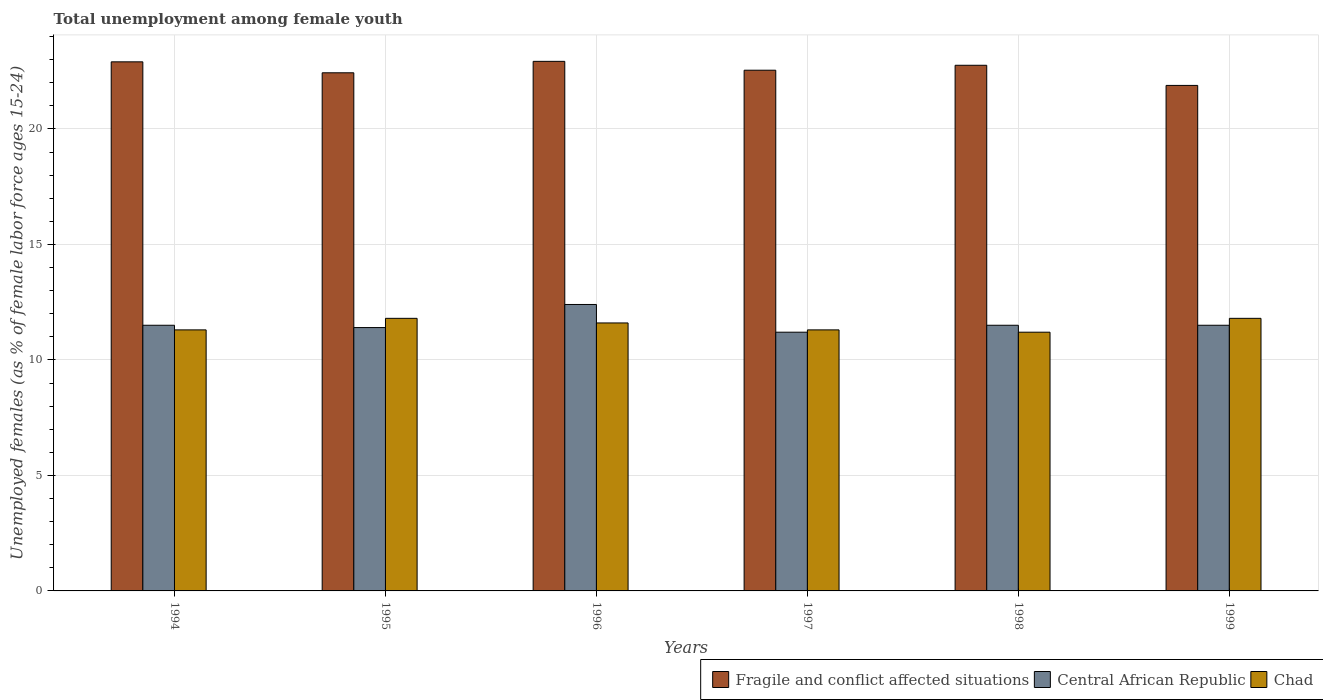How many different coloured bars are there?
Offer a very short reply. 3. How many groups of bars are there?
Your answer should be compact. 6. Are the number of bars per tick equal to the number of legend labels?
Offer a very short reply. Yes. Are the number of bars on each tick of the X-axis equal?
Your answer should be compact. Yes. How many bars are there on the 4th tick from the left?
Ensure brevity in your answer.  3. How many bars are there on the 1st tick from the right?
Make the answer very short. 3. What is the percentage of unemployed females in in Central African Republic in 1996?
Offer a very short reply. 12.4. Across all years, what is the maximum percentage of unemployed females in in Central African Republic?
Provide a short and direct response. 12.4. Across all years, what is the minimum percentage of unemployed females in in Fragile and conflict affected situations?
Your answer should be very brief. 21.88. What is the total percentage of unemployed females in in Central African Republic in the graph?
Your response must be concise. 69.5. What is the difference between the percentage of unemployed females in in Central African Republic in 1994 and that in 1995?
Give a very brief answer. 0.1. What is the difference between the percentage of unemployed females in in Fragile and conflict affected situations in 1998 and the percentage of unemployed females in in Central African Republic in 1995?
Provide a short and direct response. 11.35. What is the average percentage of unemployed females in in Fragile and conflict affected situations per year?
Ensure brevity in your answer.  22.57. In the year 1996, what is the difference between the percentage of unemployed females in in Central African Republic and percentage of unemployed females in in Fragile and conflict affected situations?
Provide a succinct answer. -10.52. What is the ratio of the percentage of unemployed females in in Chad in 1994 to that in 1996?
Provide a succinct answer. 0.97. Is the percentage of unemployed females in in Chad in 1995 less than that in 1996?
Offer a very short reply. No. What is the difference between the highest and the second highest percentage of unemployed females in in Chad?
Your answer should be compact. 0. What is the difference between the highest and the lowest percentage of unemployed females in in Fragile and conflict affected situations?
Your answer should be very brief. 1.04. What does the 2nd bar from the left in 1997 represents?
Ensure brevity in your answer.  Central African Republic. What does the 1st bar from the right in 1997 represents?
Your response must be concise. Chad. Is it the case that in every year, the sum of the percentage of unemployed females in in Chad and percentage of unemployed females in in Central African Republic is greater than the percentage of unemployed females in in Fragile and conflict affected situations?
Provide a short and direct response. No. How many years are there in the graph?
Provide a short and direct response. 6. Are the values on the major ticks of Y-axis written in scientific E-notation?
Ensure brevity in your answer.  No. What is the title of the graph?
Keep it short and to the point. Total unemployment among female youth. What is the label or title of the X-axis?
Your answer should be very brief. Years. What is the label or title of the Y-axis?
Your answer should be very brief. Unemployed females (as % of female labor force ages 15-24). What is the Unemployed females (as % of female labor force ages 15-24) of Fragile and conflict affected situations in 1994?
Provide a succinct answer. 22.9. What is the Unemployed females (as % of female labor force ages 15-24) of Central African Republic in 1994?
Keep it short and to the point. 11.5. What is the Unemployed females (as % of female labor force ages 15-24) of Chad in 1994?
Give a very brief answer. 11.3. What is the Unemployed females (as % of female labor force ages 15-24) of Fragile and conflict affected situations in 1995?
Ensure brevity in your answer.  22.43. What is the Unemployed females (as % of female labor force ages 15-24) of Central African Republic in 1995?
Offer a very short reply. 11.4. What is the Unemployed females (as % of female labor force ages 15-24) in Chad in 1995?
Provide a succinct answer. 11.8. What is the Unemployed females (as % of female labor force ages 15-24) in Fragile and conflict affected situations in 1996?
Keep it short and to the point. 22.92. What is the Unemployed females (as % of female labor force ages 15-24) in Central African Republic in 1996?
Ensure brevity in your answer.  12.4. What is the Unemployed females (as % of female labor force ages 15-24) in Chad in 1996?
Offer a terse response. 11.6. What is the Unemployed females (as % of female labor force ages 15-24) in Fragile and conflict affected situations in 1997?
Your response must be concise. 22.54. What is the Unemployed females (as % of female labor force ages 15-24) in Central African Republic in 1997?
Your answer should be compact. 11.2. What is the Unemployed females (as % of female labor force ages 15-24) of Chad in 1997?
Make the answer very short. 11.3. What is the Unemployed females (as % of female labor force ages 15-24) of Fragile and conflict affected situations in 1998?
Your answer should be very brief. 22.75. What is the Unemployed females (as % of female labor force ages 15-24) in Chad in 1998?
Provide a succinct answer. 11.2. What is the Unemployed females (as % of female labor force ages 15-24) of Fragile and conflict affected situations in 1999?
Give a very brief answer. 21.88. What is the Unemployed females (as % of female labor force ages 15-24) in Central African Republic in 1999?
Keep it short and to the point. 11.5. What is the Unemployed females (as % of female labor force ages 15-24) of Chad in 1999?
Keep it short and to the point. 11.8. Across all years, what is the maximum Unemployed females (as % of female labor force ages 15-24) of Fragile and conflict affected situations?
Offer a very short reply. 22.92. Across all years, what is the maximum Unemployed females (as % of female labor force ages 15-24) of Central African Republic?
Give a very brief answer. 12.4. Across all years, what is the maximum Unemployed females (as % of female labor force ages 15-24) of Chad?
Keep it short and to the point. 11.8. Across all years, what is the minimum Unemployed females (as % of female labor force ages 15-24) of Fragile and conflict affected situations?
Offer a terse response. 21.88. Across all years, what is the minimum Unemployed females (as % of female labor force ages 15-24) of Central African Republic?
Provide a succinct answer. 11.2. Across all years, what is the minimum Unemployed females (as % of female labor force ages 15-24) of Chad?
Give a very brief answer. 11.2. What is the total Unemployed females (as % of female labor force ages 15-24) in Fragile and conflict affected situations in the graph?
Your answer should be compact. 135.43. What is the total Unemployed females (as % of female labor force ages 15-24) of Central African Republic in the graph?
Your answer should be compact. 69.5. What is the difference between the Unemployed females (as % of female labor force ages 15-24) in Fragile and conflict affected situations in 1994 and that in 1995?
Ensure brevity in your answer.  0.47. What is the difference between the Unemployed females (as % of female labor force ages 15-24) in Fragile and conflict affected situations in 1994 and that in 1996?
Your response must be concise. -0.02. What is the difference between the Unemployed females (as % of female labor force ages 15-24) in Fragile and conflict affected situations in 1994 and that in 1997?
Provide a succinct answer. 0.36. What is the difference between the Unemployed females (as % of female labor force ages 15-24) in Fragile and conflict affected situations in 1994 and that in 1998?
Provide a short and direct response. 0.15. What is the difference between the Unemployed females (as % of female labor force ages 15-24) of Chad in 1994 and that in 1998?
Offer a very short reply. 0.1. What is the difference between the Unemployed females (as % of female labor force ages 15-24) of Fragile and conflict affected situations in 1994 and that in 1999?
Provide a succinct answer. 1.02. What is the difference between the Unemployed females (as % of female labor force ages 15-24) in Central African Republic in 1994 and that in 1999?
Keep it short and to the point. 0. What is the difference between the Unemployed females (as % of female labor force ages 15-24) in Chad in 1994 and that in 1999?
Your answer should be compact. -0.5. What is the difference between the Unemployed females (as % of female labor force ages 15-24) of Fragile and conflict affected situations in 1995 and that in 1996?
Offer a very short reply. -0.5. What is the difference between the Unemployed females (as % of female labor force ages 15-24) in Central African Republic in 1995 and that in 1996?
Give a very brief answer. -1. What is the difference between the Unemployed females (as % of female labor force ages 15-24) in Chad in 1995 and that in 1996?
Provide a short and direct response. 0.2. What is the difference between the Unemployed females (as % of female labor force ages 15-24) in Fragile and conflict affected situations in 1995 and that in 1997?
Your response must be concise. -0.11. What is the difference between the Unemployed females (as % of female labor force ages 15-24) in Fragile and conflict affected situations in 1995 and that in 1998?
Your answer should be very brief. -0.33. What is the difference between the Unemployed females (as % of female labor force ages 15-24) of Central African Republic in 1995 and that in 1998?
Offer a very short reply. -0.1. What is the difference between the Unemployed females (as % of female labor force ages 15-24) of Chad in 1995 and that in 1998?
Your response must be concise. 0.6. What is the difference between the Unemployed females (as % of female labor force ages 15-24) of Fragile and conflict affected situations in 1995 and that in 1999?
Ensure brevity in your answer.  0.55. What is the difference between the Unemployed females (as % of female labor force ages 15-24) of Central African Republic in 1995 and that in 1999?
Your response must be concise. -0.1. What is the difference between the Unemployed females (as % of female labor force ages 15-24) in Chad in 1995 and that in 1999?
Give a very brief answer. 0. What is the difference between the Unemployed females (as % of female labor force ages 15-24) of Fragile and conflict affected situations in 1996 and that in 1997?
Offer a terse response. 0.38. What is the difference between the Unemployed females (as % of female labor force ages 15-24) of Chad in 1996 and that in 1997?
Provide a short and direct response. 0.3. What is the difference between the Unemployed females (as % of female labor force ages 15-24) of Fragile and conflict affected situations in 1996 and that in 1998?
Provide a short and direct response. 0.17. What is the difference between the Unemployed females (as % of female labor force ages 15-24) in Central African Republic in 1996 and that in 1998?
Ensure brevity in your answer.  0.9. What is the difference between the Unemployed females (as % of female labor force ages 15-24) of Fragile and conflict affected situations in 1996 and that in 1999?
Offer a terse response. 1.04. What is the difference between the Unemployed females (as % of female labor force ages 15-24) of Central African Republic in 1996 and that in 1999?
Ensure brevity in your answer.  0.9. What is the difference between the Unemployed females (as % of female labor force ages 15-24) in Chad in 1996 and that in 1999?
Keep it short and to the point. -0.2. What is the difference between the Unemployed females (as % of female labor force ages 15-24) of Fragile and conflict affected situations in 1997 and that in 1998?
Offer a very short reply. -0.21. What is the difference between the Unemployed females (as % of female labor force ages 15-24) in Fragile and conflict affected situations in 1997 and that in 1999?
Ensure brevity in your answer.  0.66. What is the difference between the Unemployed females (as % of female labor force ages 15-24) in Chad in 1997 and that in 1999?
Give a very brief answer. -0.5. What is the difference between the Unemployed females (as % of female labor force ages 15-24) in Fragile and conflict affected situations in 1998 and that in 1999?
Make the answer very short. 0.87. What is the difference between the Unemployed females (as % of female labor force ages 15-24) of Central African Republic in 1998 and that in 1999?
Provide a short and direct response. 0. What is the difference between the Unemployed females (as % of female labor force ages 15-24) of Fragile and conflict affected situations in 1994 and the Unemployed females (as % of female labor force ages 15-24) of Central African Republic in 1995?
Your response must be concise. 11.5. What is the difference between the Unemployed females (as % of female labor force ages 15-24) in Fragile and conflict affected situations in 1994 and the Unemployed females (as % of female labor force ages 15-24) in Chad in 1995?
Provide a short and direct response. 11.1. What is the difference between the Unemployed females (as % of female labor force ages 15-24) of Central African Republic in 1994 and the Unemployed females (as % of female labor force ages 15-24) of Chad in 1995?
Provide a succinct answer. -0.3. What is the difference between the Unemployed females (as % of female labor force ages 15-24) in Fragile and conflict affected situations in 1994 and the Unemployed females (as % of female labor force ages 15-24) in Central African Republic in 1996?
Keep it short and to the point. 10.5. What is the difference between the Unemployed females (as % of female labor force ages 15-24) of Fragile and conflict affected situations in 1994 and the Unemployed females (as % of female labor force ages 15-24) of Chad in 1996?
Keep it short and to the point. 11.3. What is the difference between the Unemployed females (as % of female labor force ages 15-24) of Fragile and conflict affected situations in 1994 and the Unemployed females (as % of female labor force ages 15-24) of Central African Republic in 1997?
Ensure brevity in your answer.  11.7. What is the difference between the Unemployed females (as % of female labor force ages 15-24) of Fragile and conflict affected situations in 1994 and the Unemployed females (as % of female labor force ages 15-24) of Chad in 1997?
Give a very brief answer. 11.6. What is the difference between the Unemployed females (as % of female labor force ages 15-24) in Central African Republic in 1994 and the Unemployed females (as % of female labor force ages 15-24) in Chad in 1997?
Keep it short and to the point. 0.2. What is the difference between the Unemployed females (as % of female labor force ages 15-24) of Fragile and conflict affected situations in 1994 and the Unemployed females (as % of female labor force ages 15-24) of Central African Republic in 1998?
Give a very brief answer. 11.4. What is the difference between the Unemployed females (as % of female labor force ages 15-24) in Fragile and conflict affected situations in 1994 and the Unemployed females (as % of female labor force ages 15-24) in Chad in 1998?
Ensure brevity in your answer.  11.7. What is the difference between the Unemployed females (as % of female labor force ages 15-24) of Central African Republic in 1994 and the Unemployed females (as % of female labor force ages 15-24) of Chad in 1998?
Offer a very short reply. 0.3. What is the difference between the Unemployed females (as % of female labor force ages 15-24) of Fragile and conflict affected situations in 1994 and the Unemployed females (as % of female labor force ages 15-24) of Central African Republic in 1999?
Ensure brevity in your answer.  11.4. What is the difference between the Unemployed females (as % of female labor force ages 15-24) in Fragile and conflict affected situations in 1994 and the Unemployed females (as % of female labor force ages 15-24) in Chad in 1999?
Offer a terse response. 11.1. What is the difference between the Unemployed females (as % of female labor force ages 15-24) of Central African Republic in 1994 and the Unemployed females (as % of female labor force ages 15-24) of Chad in 1999?
Offer a terse response. -0.3. What is the difference between the Unemployed females (as % of female labor force ages 15-24) of Fragile and conflict affected situations in 1995 and the Unemployed females (as % of female labor force ages 15-24) of Central African Republic in 1996?
Offer a terse response. 10.03. What is the difference between the Unemployed females (as % of female labor force ages 15-24) in Fragile and conflict affected situations in 1995 and the Unemployed females (as % of female labor force ages 15-24) in Chad in 1996?
Keep it short and to the point. 10.83. What is the difference between the Unemployed females (as % of female labor force ages 15-24) of Fragile and conflict affected situations in 1995 and the Unemployed females (as % of female labor force ages 15-24) of Central African Republic in 1997?
Give a very brief answer. 11.23. What is the difference between the Unemployed females (as % of female labor force ages 15-24) of Fragile and conflict affected situations in 1995 and the Unemployed females (as % of female labor force ages 15-24) of Chad in 1997?
Keep it short and to the point. 11.13. What is the difference between the Unemployed females (as % of female labor force ages 15-24) of Fragile and conflict affected situations in 1995 and the Unemployed females (as % of female labor force ages 15-24) of Central African Republic in 1998?
Your answer should be very brief. 10.93. What is the difference between the Unemployed females (as % of female labor force ages 15-24) of Fragile and conflict affected situations in 1995 and the Unemployed females (as % of female labor force ages 15-24) of Chad in 1998?
Offer a terse response. 11.23. What is the difference between the Unemployed females (as % of female labor force ages 15-24) in Fragile and conflict affected situations in 1995 and the Unemployed females (as % of female labor force ages 15-24) in Central African Republic in 1999?
Provide a short and direct response. 10.93. What is the difference between the Unemployed females (as % of female labor force ages 15-24) in Fragile and conflict affected situations in 1995 and the Unemployed females (as % of female labor force ages 15-24) in Chad in 1999?
Provide a succinct answer. 10.63. What is the difference between the Unemployed females (as % of female labor force ages 15-24) in Fragile and conflict affected situations in 1996 and the Unemployed females (as % of female labor force ages 15-24) in Central African Republic in 1997?
Give a very brief answer. 11.72. What is the difference between the Unemployed females (as % of female labor force ages 15-24) of Fragile and conflict affected situations in 1996 and the Unemployed females (as % of female labor force ages 15-24) of Chad in 1997?
Provide a succinct answer. 11.62. What is the difference between the Unemployed females (as % of female labor force ages 15-24) of Fragile and conflict affected situations in 1996 and the Unemployed females (as % of female labor force ages 15-24) of Central African Republic in 1998?
Provide a short and direct response. 11.42. What is the difference between the Unemployed females (as % of female labor force ages 15-24) in Fragile and conflict affected situations in 1996 and the Unemployed females (as % of female labor force ages 15-24) in Chad in 1998?
Keep it short and to the point. 11.72. What is the difference between the Unemployed females (as % of female labor force ages 15-24) of Fragile and conflict affected situations in 1996 and the Unemployed females (as % of female labor force ages 15-24) of Central African Republic in 1999?
Your response must be concise. 11.42. What is the difference between the Unemployed females (as % of female labor force ages 15-24) of Fragile and conflict affected situations in 1996 and the Unemployed females (as % of female labor force ages 15-24) of Chad in 1999?
Your response must be concise. 11.12. What is the difference between the Unemployed females (as % of female labor force ages 15-24) in Central African Republic in 1996 and the Unemployed females (as % of female labor force ages 15-24) in Chad in 1999?
Keep it short and to the point. 0.6. What is the difference between the Unemployed females (as % of female labor force ages 15-24) in Fragile and conflict affected situations in 1997 and the Unemployed females (as % of female labor force ages 15-24) in Central African Republic in 1998?
Your answer should be very brief. 11.04. What is the difference between the Unemployed females (as % of female labor force ages 15-24) of Fragile and conflict affected situations in 1997 and the Unemployed females (as % of female labor force ages 15-24) of Chad in 1998?
Your answer should be very brief. 11.34. What is the difference between the Unemployed females (as % of female labor force ages 15-24) in Central African Republic in 1997 and the Unemployed females (as % of female labor force ages 15-24) in Chad in 1998?
Your answer should be compact. 0. What is the difference between the Unemployed females (as % of female labor force ages 15-24) in Fragile and conflict affected situations in 1997 and the Unemployed females (as % of female labor force ages 15-24) in Central African Republic in 1999?
Provide a succinct answer. 11.04. What is the difference between the Unemployed females (as % of female labor force ages 15-24) of Fragile and conflict affected situations in 1997 and the Unemployed females (as % of female labor force ages 15-24) of Chad in 1999?
Make the answer very short. 10.74. What is the difference between the Unemployed females (as % of female labor force ages 15-24) of Fragile and conflict affected situations in 1998 and the Unemployed females (as % of female labor force ages 15-24) of Central African Republic in 1999?
Ensure brevity in your answer.  11.25. What is the difference between the Unemployed females (as % of female labor force ages 15-24) of Fragile and conflict affected situations in 1998 and the Unemployed females (as % of female labor force ages 15-24) of Chad in 1999?
Give a very brief answer. 10.95. What is the difference between the Unemployed females (as % of female labor force ages 15-24) of Central African Republic in 1998 and the Unemployed females (as % of female labor force ages 15-24) of Chad in 1999?
Make the answer very short. -0.3. What is the average Unemployed females (as % of female labor force ages 15-24) in Fragile and conflict affected situations per year?
Your answer should be compact. 22.57. What is the average Unemployed females (as % of female labor force ages 15-24) of Central African Republic per year?
Your response must be concise. 11.58. What is the average Unemployed females (as % of female labor force ages 15-24) in Chad per year?
Make the answer very short. 11.5. In the year 1994, what is the difference between the Unemployed females (as % of female labor force ages 15-24) of Fragile and conflict affected situations and Unemployed females (as % of female labor force ages 15-24) of Central African Republic?
Ensure brevity in your answer.  11.4. In the year 1994, what is the difference between the Unemployed females (as % of female labor force ages 15-24) in Fragile and conflict affected situations and Unemployed females (as % of female labor force ages 15-24) in Chad?
Your answer should be compact. 11.6. In the year 1994, what is the difference between the Unemployed females (as % of female labor force ages 15-24) of Central African Republic and Unemployed females (as % of female labor force ages 15-24) of Chad?
Provide a short and direct response. 0.2. In the year 1995, what is the difference between the Unemployed females (as % of female labor force ages 15-24) of Fragile and conflict affected situations and Unemployed females (as % of female labor force ages 15-24) of Central African Republic?
Keep it short and to the point. 11.03. In the year 1995, what is the difference between the Unemployed females (as % of female labor force ages 15-24) of Fragile and conflict affected situations and Unemployed females (as % of female labor force ages 15-24) of Chad?
Give a very brief answer. 10.63. In the year 1996, what is the difference between the Unemployed females (as % of female labor force ages 15-24) in Fragile and conflict affected situations and Unemployed females (as % of female labor force ages 15-24) in Central African Republic?
Your response must be concise. 10.52. In the year 1996, what is the difference between the Unemployed females (as % of female labor force ages 15-24) of Fragile and conflict affected situations and Unemployed females (as % of female labor force ages 15-24) of Chad?
Keep it short and to the point. 11.32. In the year 1996, what is the difference between the Unemployed females (as % of female labor force ages 15-24) in Central African Republic and Unemployed females (as % of female labor force ages 15-24) in Chad?
Your answer should be very brief. 0.8. In the year 1997, what is the difference between the Unemployed females (as % of female labor force ages 15-24) in Fragile and conflict affected situations and Unemployed females (as % of female labor force ages 15-24) in Central African Republic?
Keep it short and to the point. 11.34. In the year 1997, what is the difference between the Unemployed females (as % of female labor force ages 15-24) of Fragile and conflict affected situations and Unemployed females (as % of female labor force ages 15-24) of Chad?
Offer a very short reply. 11.24. In the year 1998, what is the difference between the Unemployed females (as % of female labor force ages 15-24) of Fragile and conflict affected situations and Unemployed females (as % of female labor force ages 15-24) of Central African Republic?
Your response must be concise. 11.25. In the year 1998, what is the difference between the Unemployed females (as % of female labor force ages 15-24) of Fragile and conflict affected situations and Unemployed females (as % of female labor force ages 15-24) of Chad?
Provide a short and direct response. 11.55. In the year 1998, what is the difference between the Unemployed females (as % of female labor force ages 15-24) in Central African Republic and Unemployed females (as % of female labor force ages 15-24) in Chad?
Your answer should be very brief. 0.3. In the year 1999, what is the difference between the Unemployed females (as % of female labor force ages 15-24) of Fragile and conflict affected situations and Unemployed females (as % of female labor force ages 15-24) of Central African Republic?
Your answer should be compact. 10.38. In the year 1999, what is the difference between the Unemployed females (as % of female labor force ages 15-24) of Fragile and conflict affected situations and Unemployed females (as % of female labor force ages 15-24) of Chad?
Keep it short and to the point. 10.08. In the year 1999, what is the difference between the Unemployed females (as % of female labor force ages 15-24) of Central African Republic and Unemployed females (as % of female labor force ages 15-24) of Chad?
Offer a terse response. -0.3. What is the ratio of the Unemployed females (as % of female labor force ages 15-24) of Fragile and conflict affected situations in 1994 to that in 1995?
Provide a short and direct response. 1.02. What is the ratio of the Unemployed females (as % of female labor force ages 15-24) of Central African Republic in 1994 to that in 1995?
Your answer should be compact. 1.01. What is the ratio of the Unemployed females (as % of female labor force ages 15-24) of Chad in 1994 to that in 1995?
Offer a terse response. 0.96. What is the ratio of the Unemployed females (as % of female labor force ages 15-24) of Fragile and conflict affected situations in 1994 to that in 1996?
Your answer should be compact. 1. What is the ratio of the Unemployed females (as % of female labor force ages 15-24) in Central African Republic in 1994 to that in 1996?
Ensure brevity in your answer.  0.93. What is the ratio of the Unemployed females (as % of female labor force ages 15-24) of Chad in 1994 to that in 1996?
Provide a succinct answer. 0.97. What is the ratio of the Unemployed females (as % of female labor force ages 15-24) in Fragile and conflict affected situations in 1994 to that in 1997?
Keep it short and to the point. 1.02. What is the ratio of the Unemployed females (as % of female labor force ages 15-24) of Central African Republic in 1994 to that in 1997?
Offer a terse response. 1.03. What is the ratio of the Unemployed females (as % of female labor force ages 15-24) in Chad in 1994 to that in 1998?
Provide a short and direct response. 1.01. What is the ratio of the Unemployed females (as % of female labor force ages 15-24) of Fragile and conflict affected situations in 1994 to that in 1999?
Ensure brevity in your answer.  1.05. What is the ratio of the Unemployed females (as % of female labor force ages 15-24) of Chad in 1994 to that in 1999?
Your answer should be very brief. 0.96. What is the ratio of the Unemployed females (as % of female labor force ages 15-24) in Fragile and conflict affected situations in 1995 to that in 1996?
Provide a short and direct response. 0.98. What is the ratio of the Unemployed females (as % of female labor force ages 15-24) of Central African Republic in 1995 to that in 1996?
Provide a short and direct response. 0.92. What is the ratio of the Unemployed females (as % of female labor force ages 15-24) in Chad in 1995 to that in 1996?
Ensure brevity in your answer.  1.02. What is the ratio of the Unemployed females (as % of female labor force ages 15-24) in Central African Republic in 1995 to that in 1997?
Provide a short and direct response. 1.02. What is the ratio of the Unemployed females (as % of female labor force ages 15-24) of Chad in 1995 to that in 1997?
Offer a terse response. 1.04. What is the ratio of the Unemployed females (as % of female labor force ages 15-24) of Fragile and conflict affected situations in 1995 to that in 1998?
Provide a succinct answer. 0.99. What is the ratio of the Unemployed females (as % of female labor force ages 15-24) of Central African Republic in 1995 to that in 1998?
Your response must be concise. 0.99. What is the ratio of the Unemployed females (as % of female labor force ages 15-24) of Chad in 1995 to that in 1998?
Your answer should be compact. 1.05. What is the ratio of the Unemployed females (as % of female labor force ages 15-24) of Fragile and conflict affected situations in 1996 to that in 1997?
Keep it short and to the point. 1.02. What is the ratio of the Unemployed females (as % of female labor force ages 15-24) in Central African Republic in 1996 to that in 1997?
Your answer should be compact. 1.11. What is the ratio of the Unemployed females (as % of female labor force ages 15-24) in Chad in 1996 to that in 1997?
Ensure brevity in your answer.  1.03. What is the ratio of the Unemployed females (as % of female labor force ages 15-24) in Fragile and conflict affected situations in 1996 to that in 1998?
Your answer should be compact. 1.01. What is the ratio of the Unemployed females (as % of female labor force ages 15-24) of Central African Republic in 1996 to that in 1998?
Your response must be concise. 1.08. What is the ratio of the Unemployed females (as % of female labor force ages 15-24) of Chad in 1996 to that in 1998?
Ensure brevity in your answer.  1.04. What is the ratio of the Unemployed females (as % of female labor force ages 15-24) of Fragile and conflict affected situations in 1996 to that in 1999?
Your answer should be very brief. 1.05. What is the ratio of the Unemployed females (as % of female labor force ages 15-24) of Central African Republic in 1996 to that in 1999?
Give a very brief answer. 1.08. What is the ratio of the Unemployed females (as % of female labor force ages 15-24) of Chad in 1996 to that in 1999?
Provide a short and direct response. 0.98. What is the ratio of the Unemployed females (as % of female labor force ages 15-24) in Fragile and conflict affected situations in 1997 to that in 1998?
Offer a terse response. 0.99. What is the ratio of the Unemployed females (as % of female labor force ages 15-24) in Central African Republic in 1997 to that in 1998?
Offer a terse response. 0.97. What is the ratio of the Unemployed females (as % of female labor force ages 15-24) of Chad in 1997 to that in 1998?
Make the answer very short. 1.01. What is the ratio of the Unemployed females (as % of female labor force ages 15-24) of Fragile and conflict affected situations in 1997 to that in 1999?
Your answer should be compact. 1.03. What is the ratio of the Unemployed females (as % of female labor force ages 15-24) of Central African Republic in 1997 to that in 1999?
Your answer should be compact. 0.97. What is the ratio of the Unemployed females (as % of female labor force ages 15-24) in Chad in 1997 to that in 1999?
Your answer should be compact. 0.96. What is the ratio of the Unemployed females (as % of female labor force ages 15-24) of Fragile and conflict affected situations in 1998 to that in 1999?
Your answer should be very brief. 1.04. What is the ratio of the Unemployed females (as % of female labor force ages 15-24) of Central African Republic in 1998 to that in 1999?
Your answer should be compact. 1. What is the ratio of the Unemployed females (as % of female labor force ages 15-24) of Chad in 1998 to that in 1999?
Give a very brief answer. 0.95. What is the difference between the highest and the second highest Unemployed females (as % of female labor force ages 15-24) of Fragile and conflict affected situations?
Make the answer very short. 0.02. What is the difference between the highest and the lowest Unemployed females (as % of female labor force ages 15-24) of Fragile and conflict affected situations?
Ensure brevity in your answer.  1.04. What is the difference between the highest and the lowest Unemployed females (as % of female labor force ages 15-24) of Central African Republic?
Provide a short and direct response. 1.2. What is the difference between the highest and the lowest Unemployed females (as % of female labor force ages 15-24) of Chad?
Provide a short and direct response. 0.6. 